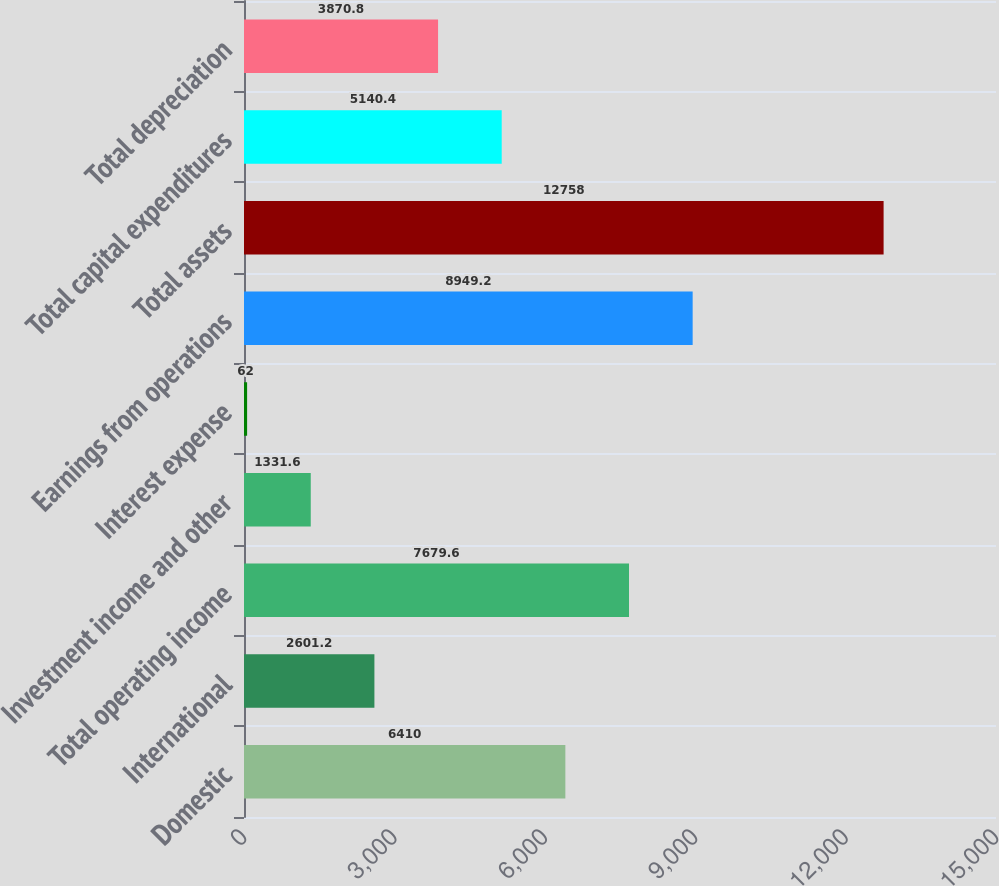Convert chart to OTSL. <chart><loc_0><loc_0><loc_500><loc_500><bar_chart><fcel>Domestic<fcel>International<fcel>Total operating income<fcel>Investment income and other<fcel>Interest expense<fcel>Earnings from operations<fcel>Total assets<fcel>Total capital expenditures<fcel>Total depreciation<nl><fcel>6410<fcel>2601.2<fcel>7679.6<fcel>1331.6<fcel>62<fcel>8949.2<fcel>12758<fcel>5140.4<fcel>3870.8<nl></chart> 